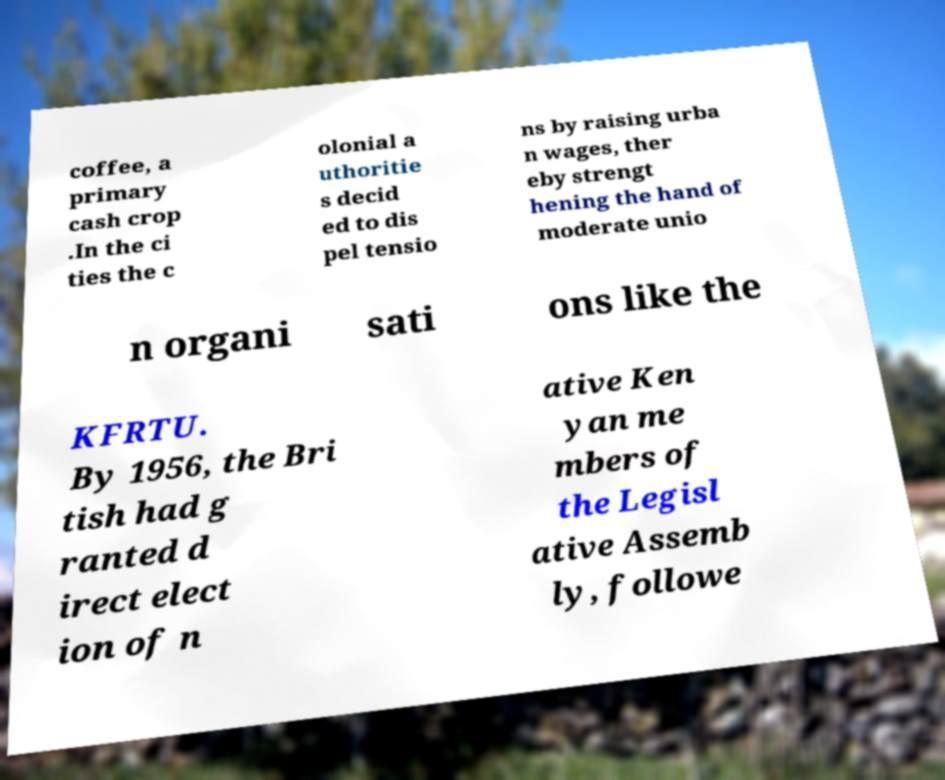Could you assist in decoding the text presented in this image and type it out clearly? coffee, a primary cash crop .In the ci ties the c olonial a uthoritie s decid ed to dis pel tensio ns by raising urba n wages, ther eby strengt hening the hand of moderate unio n organi sati ons like the KFRTU. By 1956, the Bri tish had g ranted d irect elect ion of n ative Ken yan me mbers of the Legisl ative Assemb ly, followe 